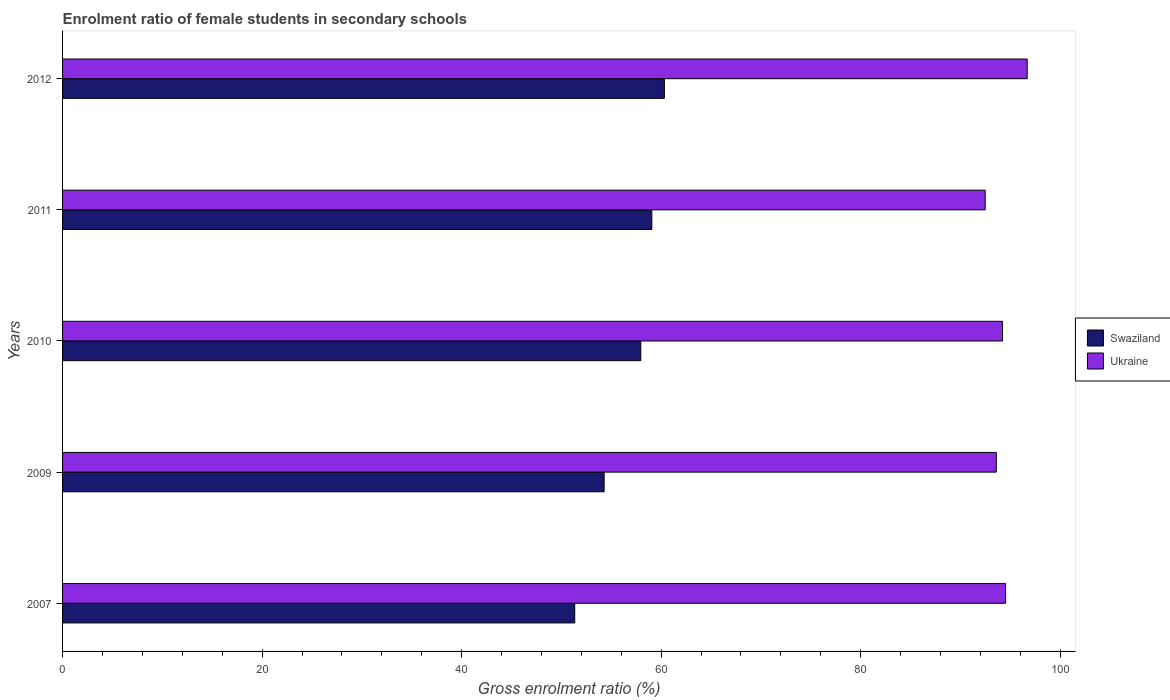How many different coloured bars are there?
Provide a succinct answer. 2. In how many cases, is the number of bars for a given year not equal to the number of legend labels?
Your answer should be compact. 0. What is the enrolment ratio of female students in secondary schools in Swaziland in 2009?
Offer a terse response. 54.28. Across all years, what is the maximum enrolment ratio of female students in secondary schools in Swaziland?
Your answer should be very brief. 60.32. Across all years, what is the minimum enrolment ratio of female students in secondary schools in Swaziland?
Ensure brevity in your answer.  51.34. In which year was the enrolment ratio of female students in secondary schools in Ukraine maximum?
Your answer should be compact. 2012. What is the total enrolment ratio of female students in secondary schools in Swaziland in the graph?
Offer a terse response. 282.97. What is the difference between the enrolment ratio of female students in secondary schools in Ukraine in 2007 and that in 2010?
Provide a succinct answer. 0.31. What is the difference between the enrolment ratio of female students in secondary schools in Swaziland in 2009 and the enrolment ratio of female students in secondary schools in Ukraine in 2012?
Give a very brief answer. -42.41. What is the average enrolment ratio of female students in secondary schools in Ukraine per year?
Offer a terse response. 94.3. In the year 2010, what is the difference between the enrolment ratio of female students in secondary schools in Ukraine and enrolment ratio of female students in secondary schools in Swaziland?
Ensure brevity in your answer.  36.26. What is the ratio of the enrolment ratio of female students in secondary schools in Swaziland in 2007 to that in 2012?
Keep it short and to the point. 0.85. Is the enrolment ratio of female students in secondary schools in Ukraine in 2009 less than that in 2010?
Your answer should be compact. Yes. Is the difference between the enrolment ratio of female students in secondary schools in Ukraine in 2009 and 2012 greater than the difference between the enrolment ratio of female students in secondary schools in Swaziland in 2009 and 2012?
Your answer should be very brief. Yes. What is the difference between the highest and the second highest enrolment ratio of female students in secondary schools in Ukraine?
Offer a very short reply. 2.16. What is the difference between the highest and the lowest enrolment ratio of female students in secondary schools in Swaziland?
Your answer should be compact. 8.99. In how many years, is the enrolment ratio of female students in secondary schools in Swaziland greater than the average enrolment ratio of female students in secondary schools in Swaziland taken over all years?
Your response must be concise. 3. Is the sum of the enrolment ratio of female students in secondary schools in Ukraine in 2007 and 2010 greater than the maximum enrolment ratio of female students in secondary schools in Swaziland across all years?
Make the answer very short. Yes. What does the 1st bar from the top in 2007 represents?
Give a very brief answer. Ukraine. What does the 1st bar from the bottom in 2010 represents?
Ensure brevity in your answer.  Swaziland. Does the graph contain any zero values?
Ensure brevity in your answer.  No. Where does the legend appear in the graph?
Ensure brevity in your answer.  Center right. What is the title of the graph?
Your answer should be very brief. Enrolment ratio of female students in secondary schools. What is the label or title of the X-axis?
Your answer should be compact. Gross enrolment ratio (%). What is the label or title of the Y-axis?
Provide a short and direct response. Years. What is the Gross enrolment ratio (%) of Swaziland in 2007?
Ensure brevity in your answer.  51.34. What is the Gross enrolment ratio (%) in Ukraine in 2007?
Keep it short and to the point. 94.53. What is the Gross enrolment ratio (%) in Swaziland in 2009?
Provide a short and direct response. 54.28. What is the Gross enrolment ratio (%) in Ukraine in 2009?
Offer a terse response. 93.6. What is the Gross enrolment ratio (%) of Swaziland in 2010?
Your answer should be compact. 57.96. What is the Gross enrolment ratio (%) of Ukraine in 2010?
Keep it short and to the point. 94.22. What is the Gross enrolment ratio (%) of Swaziland in 2011?
Provide a short and direct response. 59.07. What is the Gross enrolment ratio (%) of Ukraine in 2011?
Your answer should be very brief. 92.48. What is the Gross enrolment ratio (%) in Swaziland in 2012?
Provide a succinct answer. 60.32. What is the Gross enrolment ratio (%) of Ukraine in 2012?
Provide a short and direct response. 96.69. Across all years, what is the maximum Gross enrolment ratio (%) of Swaziland?
Offer a terse response. 60.32. Across all years, what is the maximum Gross enrolment ratio (%) of Ukraine?
Your answer should be very brief. 96.69. Across all years, what is the minimum Gross enrolment ratio (%) of Swaziland?
Your response must be concise. 51.34. Across all years, what is the minimum Gross enrolment ratio (%) in Ukraine?
Offer a terse response. 92.48. What is the total Gross enrolment ratio (%) of Swaziland in the graph?
Your answer should be compact. 282.97. What is the total Gross enrolment ratio (%) of Ukraine in the graph?
Your answer should be compact. 471.51. What is the difference between the Gross enrolment ratio (%) in Swaziland in 2007 and that in 2009?
Your answer should be compact. -2.95. What is the difference between the Gross enrolment ratio (%) of Ukraine in 2007 and that in 2009?
Your answer should be compact. 0.93. What is the difference between the Gross enrolment ratio (%) in Swaziland in 2007 and that in 2010?
Provide a succinct answer. -6.62. What is the difference between the Gross enrolment ratio (%) in Ukraine in 2007 and that in 2010?
Offer a terse response. 0.31. What is the difference between the Gross enrolment ratio (%) in Swaziland in 2007 and that in 2011?
Your answer should be compact. -7.73. What is the difference between the Gross enrolment ratio (%) in Ukraine in 2007 and that in 2011?
Ensure brevity in your answer.  2.05. What is the difference between the Gross enrolment ratio (%) of Swaziland in 2007 and that in 2012?
Your response must be concise. -8.99. What is the difference between the Gross enrolment ratio (%) of Ukraine in 2007 and that in 2012?
Keep it short and to the point. -2.16. What is the difference between the Gross enrolment ratio (%) of Swaziland in 2009 and that in 2010?
Provide a short and direct response. -3.67. What is the difference between the Gross enrolment ratio (%) in Ukraine in 2009 and that in 2010?
Offer a very short reply. -0.62. What is the difference between the Gross enrolment ratio (%) of Swaziland in 2009 and that in 2011?
Provide a succinct answer. -4.78. What is the difference between the Gross enrolment ratio (%) of Ukraine in 2009 and that in 2011?
Provide a short and direct response. 1.12. What is the difference between the Gross enrolment ratio (%) in Swaziland in 2009 and that in 2012?
Your answer should be very brief. -6.04. What is the difference between the Gross enrolment ratio (%) in Ukraine in 2009 and that in 2012?
Provide a succinct answer. -3.1. What is the difference between the Gross enrolment ratio (%) in Swaziland in 2010 and that in 2011?
Make the answer very short. -1.11. What is the difference between the Gross enrolment ratio (%) of Ukraine in 2010 and that in 2011?
Offer a terse response. 1.74. What is the difference between the Gross enrolment ratio (%) in Swaziland in 2010 and that in 2012?
Keep it short and to the point. -2.37. What is the difference between the Gross enrolment ratio (%) in Ukraine in 2010 and that in 2012?
Keep it short and to the point. -2.48. What is the difference between the Gross enrolment ratio (%) in Swaziland in 2011 and that in 2012?
Provide a succinct answer. -1.26. What is the difference between the Gross enrolment ratio (%) of Ukraine in 2011 and that in 2012?
Provide a succinct answer. -4.21. What is the difference between the Gross enrolment ratio (%) of Swaziland in 2007 and the Gross enrolment ratio (%) of Ukraine in 2009?
Your answer should be compact. -42.26. What is the difference between the Gross enrolment ratio (%) in Swaziland in 2007 and the Gross enrolment ratio (%) in Ukraine in 2010?
Give a very brief answer. -42.88. What is the difference between the Gross enrolment ratio (%) of Swaziland in 2007 and the Gross enrolment ratio (%) of Ukraine in 2011?
Provide a succinct answer. -41.14. What is the difference between the Gross enrolment ratio (%) in Swaziland in 2007 and the Gross enrolment ratio (%) in Ukraine in 2012?
Your response must be concise. -45.35. What is the difference between the Gross enrolment ratio (%) of Swaziland in 2009 and the Gross enrolment ratio (%) of Ukraine in 2010?
Give a very brief answer. -39.93. What is the difference between the Gross enrolment ratio (%) in Swaziland in 2009 and the Gross enrolment ratio (%) in Ukraine in 2011?
Your answer should be very brief. -38.2. What is the difference between the Gross enrolment ratio (%) in Swaziland in 2009 and the Gross enrolment ratio (%) in Ukraine in 2012?
Your answer should be compact. -42.41. What is the difference between the Gross enrolment ratio (%) in Swaziland in 2010 and the Gross enrolment ratio (%) in Ukraine in 2011?
Make the answer very short. -34.52. What is the difference between the Gross enrolment ratio (%) in Swaziland in 2010 and the Gross enrolment ratio (%) in Ukraine in 2012?
Provide a succinct answer. -38.73. What is the difference between the Gross enrolment ratio (%) of Swaziland in 2011 and the Gross enrolment ratio (%) of Ukraine in 2012?
Make the answer very short. -37.62. What is the average Gross enrolment ratio (%) of Swaziland per year?
Ensure brevity in your answer.  56.59. What is the average Gross enrolment ratio (%) in Ukraine per year?
Your answer should be very brief. 94.3. In the year 2007, what is the difference between the Gross enrolment ratio (%) of Swaziland and Gross enrolment ratio (%) of Ukraine?
Offer a terse response. -43.19. In the year 2009, what is the difference between the Gross enrolment ratio (%) of Swaziland and Gross enrolment ratio (%) of Ukraine?
Provide a succinct answer. -39.31. In the year 2010, what is the difference between the Gross enrolment ratio (%) of Swaziland and Gross enrolment ratio (%) of Ukraine?
Your response must be concise. -36.26. In the year 2011, what is the difference between the Gross enrolment ratio (%) in Swaziland and Gross enrolment ratio (%) in Ukraine?
Offer a terse response. -33.41. In the year 2012, what is the difference between the Gross enrolment ratio (%) in Swaziland and Gross enrolment ratio (%) in Ukraine?
Offer a very short reply. -36.37. What is the ratio of the Gross enrolment ratio (%) of Swaziland in 2007 to that in 2009?
Offer a terse response. 0.95. What is the ratio of the Gross enrolment ratio (%) in Ukraine in 2007 to that in 2009?
Keep it short and to the point. 1.01. What is the ratio of the Gross enrolment ratio (%) of Swaziland in 2007 to that in 2010?
Your response must be concise. 0.89. What is the ratio of the Gross enrolment ratio (%) in Ukraine in 2007 to that in 2010?
Make the answer very short. 1. What is the ratio of the Gross enrolment ratio (%) in Swaziland in 2007 to that in 2011?
Offer a very short reply. 0.87. What is the ratio of the Gross enrolment ratio (%) of Ukraine in 2007 to that in 2011?
Your response must be concise. 1.02. What is the ratio of the Gross enrolment ratio (%) in Swaziland in 2007 to that in 2012?
Offer a very short reply. 0.85. What is the ratio of the Gross enrolment ratio (%) in Ukraine in 2007 to that in 2012?
Your answer should be compact. 0.98. What is the ratio of the Gross enrolment ratio (%) of Swaziland in 2009 to that in 2010?
Your response must be concise. 0.94. What is the ratio of the Gross enrolment ratio (%) in Swaziland in 2009 to that in 2011?
Keep it short and to the point. 0.92. What is the ratio of the Gross enrolment ratio (%) of Ukraine in 2009 to that in 2011?
Provide a succinct answer. 1.01. What is the ratio of the Gross enrolment ratio (%) in Swaziland in 2009 to that in 2012?
Make the answer very short. 0.9. What is the ratio of the Gross enrolment ratio (%) in Ukraine in 2009 to that in 2012?
Keep it short and to the point. 0.97. What is the ratio of the Gross enrolment ratio (%) in Swaziland in 2010 to that in 2011?
Provide a short and direct response. 0.98. What is the ratio of the Gross enrolment ratio (%) of Ukraine in 2010 to that in 2011?
Your answer should be very brief. 1.02. What is the ratio of the Gross enrolment ratio (%) of Swaziland in 2010 to that in 2012?
Give a very brief answer. 0.96. What is the ratio of the Gross enrolment ratio (%) of Ukraine in 2010 to that in 2012?
Ensure brevity in your answer.  0.97. What is the ratio of the Gross enrolment ratio (%) of Swaziland in 2011 to that in 2012?
Ensure brevity in your answer.  0.98. What is the ratio of the Gross enrolment ratio (%) of Ukraine in 2011 to that in 2012?
Your response must be concise. 0.96. What is the difference between the highest and the second highest Gross enrolment ratio (%) in Swaziland?
Your answer should be very brief. 1.26. What is the difference between the highest and the second highest Gross enrolment ratio (%) of Ukraine?
Give a very brief answer. 2.16. What is the difference between the highest and the lowest Gross enrolment ratio (%) in Swaziland?
Make the answer very short. 8.99. What is the difference between the highest and the lowest Gross enrolment ratio (%) of Ukraine?
Offer a very short reply. 4.21. 